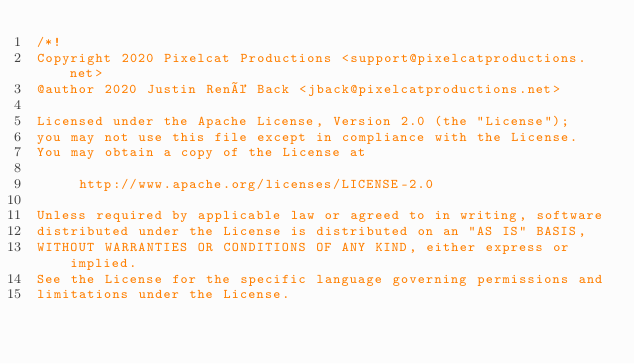<code> <loc_0><loc_0><loc_500><loc_500><_CSS_>/*!
Copyright 2020 Pixelcat Productions <support@pixelcatproductions.net>
@author 2020 Justin René Back <jback@pixelcatproductions.net>

Licensed under the Apache License, Version 2.0 (the "License");
you may not use this file except in compliance with the License.
You may obtain a copy of the License at

     http://www.apache.org/licenses/LICENSE-2.0

Unless required by applicable law or agreed to in writing, software
distributed under the License is distributed on an "AS IS" BASIS,
WITHOUT WARRANTIES OR CONDITIONS OF ANY KIND, either express or implied.
See the License for the specific language governing permissions and
limitations under the License.</code> 